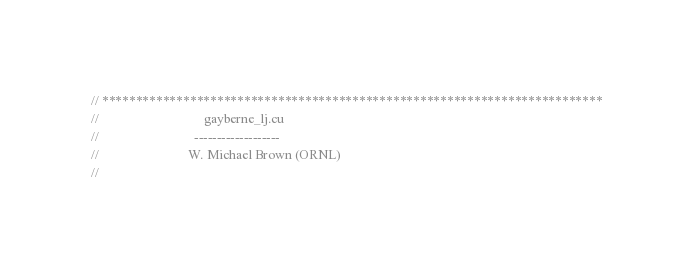Convert code to text. <code><loc_0><loc_0><loc_500><loc_500><_Cuda_>// **************************************************************************
//                                gayberne_lj.cu
//                             -------------------
//                           W. Michael Brown (ORNL)
//</code> 